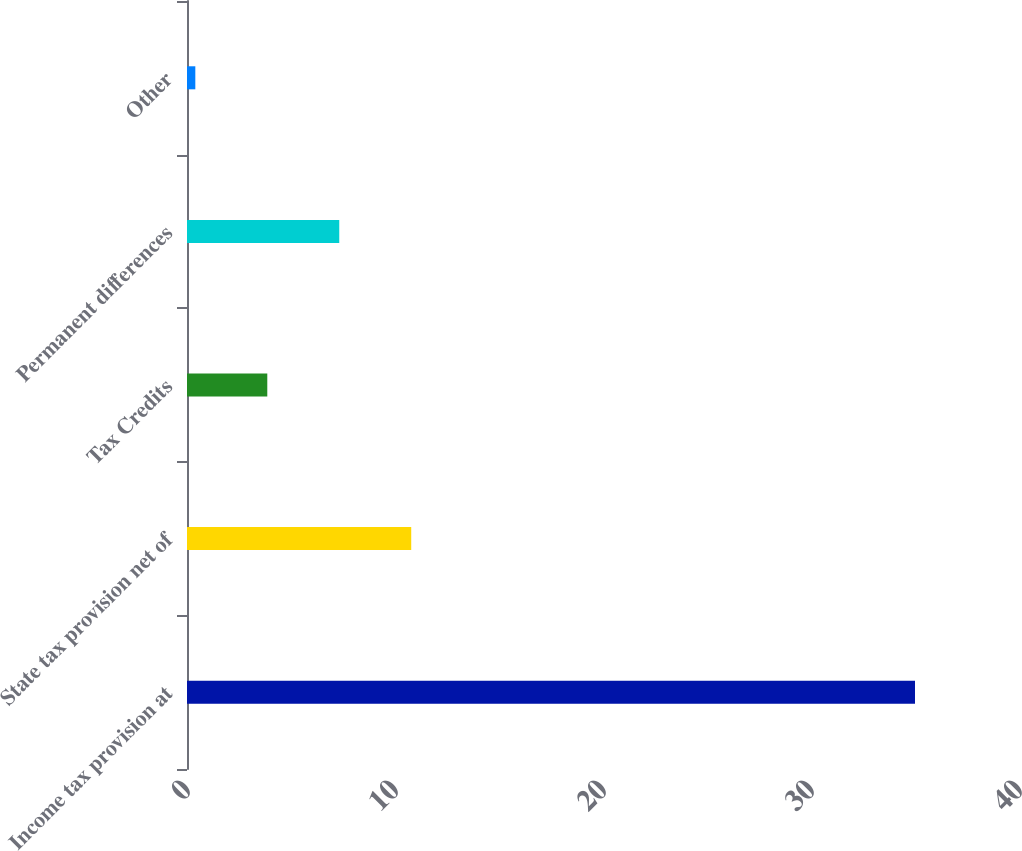Convert chart to OTSL. <chart><loc_0><loc_0><loc_500><loc_500><bar_chart><fcel>Income tax provision at<fcel>State tax provision net of<fcel>Tax Credits<fcel>Permanent differences<fcel>Other<nl><fcel>35<fcel>10.78<fcel>3.86<fcel>7.32<fcel>0.4<nl></chart> 